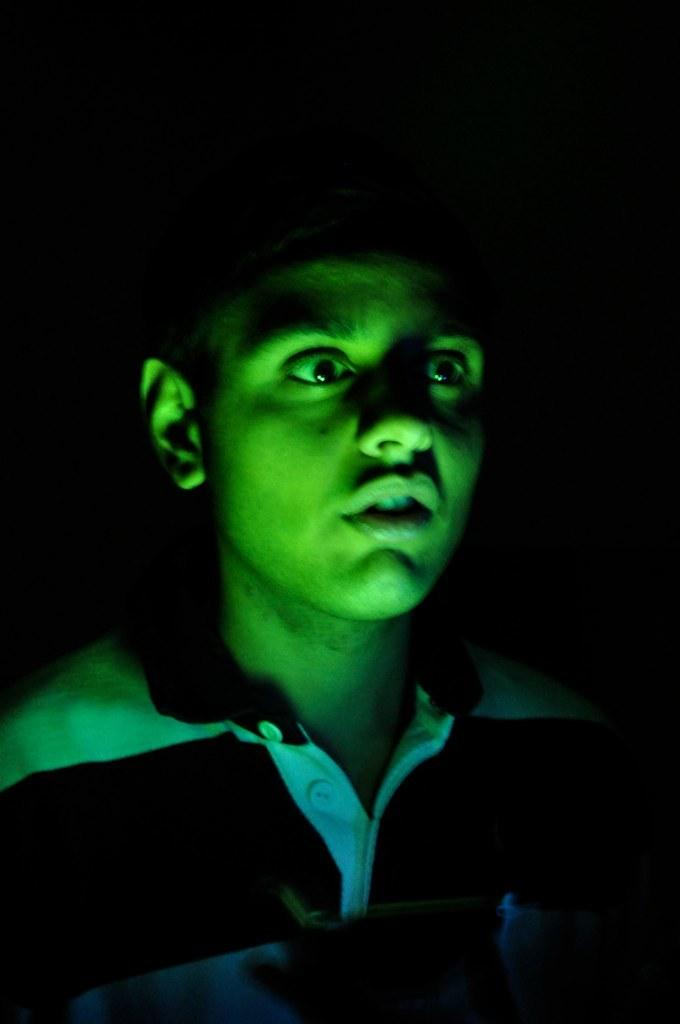Who is the main subject in the picture? There is a boy in the picture. What is the boy wearing? The boy is wearing a T-shirt. How would you describe the boy's facial expression? The boy's face expression is stunned. What can be seen on the boy's face? There is a green color focus light on the boy's face. Are there any cobwebs visible on the boy's face in the image? No, there are no cobwebs visible on the boy's face in the image. 